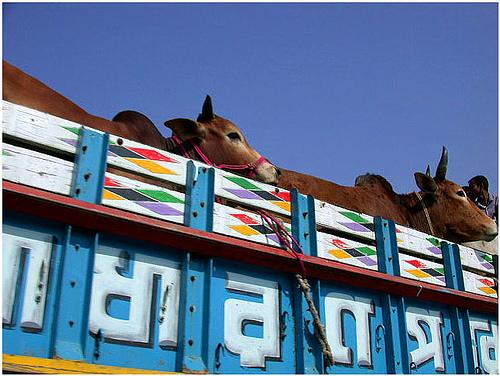Do the animals appear to be stressed?
Concise answer only. No. Do the animals have horns?
Be succinct. Yes. Is there anything written?
Answer briefly. Yes. 